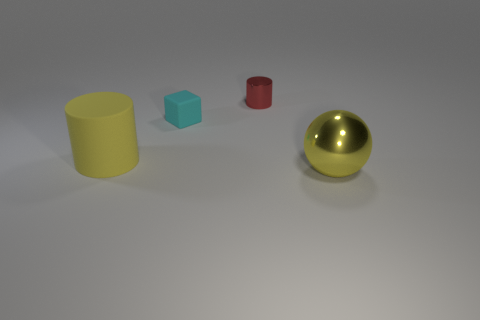Is the color of the large metallic thing the same as the matte cylinder?
Offer a terse response. Yes. What color is the object that is the same size as the cyan cube?
Ensure brevity in your answer.  Red. What number of purple things are either small cylinders or large cylinders?
Give a very brief answer. 0. Are there more tiny yellow cylinders than metallic cylinders?
Keep it short and to the point. No. Does the metallic thing that is in front of the small red thing have the same size as the shiny thing behind the metallic sphere?
Your answer should be very brief. No. What color is the big object to the left of the yellow object to the right of the shiny thing behind the yellow cylinder?
Your answer should be very brief. Yellow. Are there any yellow rubber things that have the same shape as the red object?
Keep it short and to the point. Yes. Are there more rubber objects in front of the cyan rubber object than red rubber things?
Make the answer very short. Yes. What number of rubber things are tiny objects or cylinders?
Keep it short and to the point. 2. What is the size of the thing that is behind the matte cylinder and in front of the red object?
Your answer should be compact. Small. 